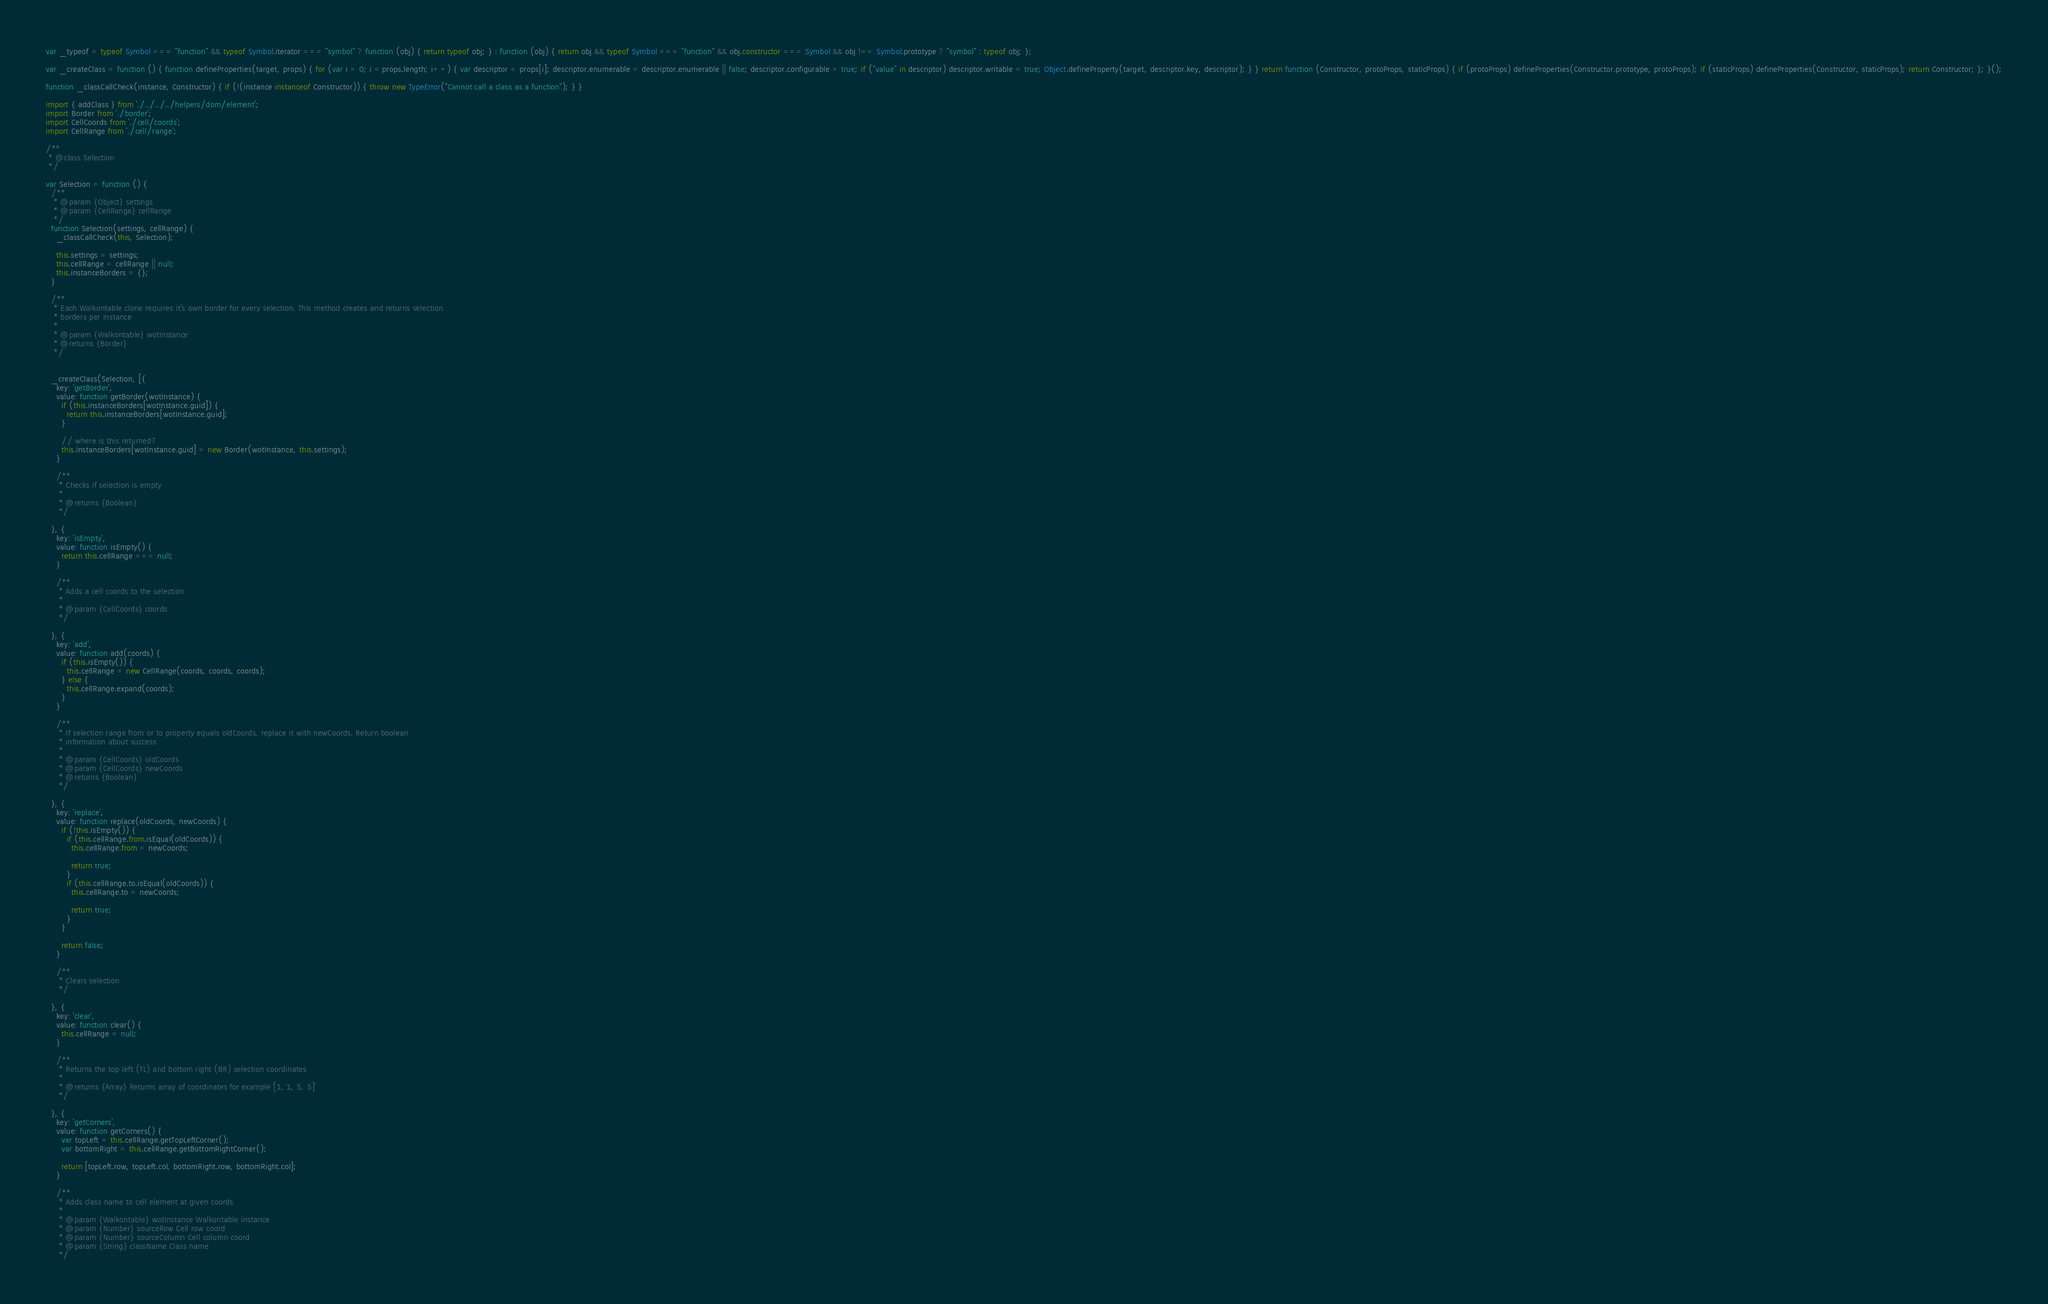Convert code to text. <code><loc_0><loc_0><loc_500><loc_500><_JavaScript_>var _typeof = typeof Symbol === "function" && typeof Symbol.iterator === "symbol" ? function (obj) { return typeof obj; } : function (obj) { return obj && typeof Symbol === "function" && obj.constructor === Symbol && obj !== Symbol.prototype ? "symbol" : typeof obj; };

var _createClass = function () { function defineProperties(target, props) { for (var i = 0; i < props.length; i++) { var descriptor = props[i]; descriptor.enumerable = descriptor.enumerable || false; descriptor.configurable = true; if ("value" in descriptor) descriptor.writable = true; Object.defineProperty(target, descriptor.key, descriptor); } } return function (Constructor, protoProps, staticProps) { if (protoProps) defineProperties(Constructor.prototype, protoProps); if (staticProps) defineProperties(Constructor, staticProps); return Constructor; }; }();

function _classCallCheck(instance, Constructor) { if (!(instance instanceof Constructor)) { throw new TypeError("Cannot call a class as a function"); } }

import { addClass } from './../../../helpers/dom/element';
import Border from './border';
import CellCoords from './cell/coords';
import CellRange from './cell/range';

/**
 * @class Selection
 */

var Selection = function () {
  /**
   * @param {Object} settings
   * @param {CellRange} cellRange
   */
  function Selection(settings, cellRange) {
    _classCallCheck(this, Selection);

    this.settings = settings;
    this.cellRange = cellRange || null;
    this.instanceBorders = {};
  }

  /**
   * Each Walkontable clone requires it's own border for every selection. This method creates and returns selection
   * borders per instance
   *
   * @param {Walkontable} wotInstance
   * @returns {Border}
   */


  _createClass(Selection, [{
    key: 'getBorder',
    value: function getBorder(wotInstance) {
      if (this.instanceBorders[wotInstance.guid]) {
        return this.instanceBorders[wotInstance.guid];
      }

      // where is this returned?
      this.instanceBorders[wotInstance.guid] = new Border(wotInstance, this.settings);
    }

    /**
     * Checks if selection is empty
     *
     * @returns {Boolean}
     */

  }, {
    key: 'isEmpty',
    value: function isEmpty() {
      return this.cellRange === null;
    }

    /**
     * Adds a cell coords to the selection
     *
     * @param {CellCoords} coords
     */

  }, {
    key: 'add',
    value: function add(coords) {
      if (this.isEmpty()) {
        this.cellRange = new CellRange(coords, coords, coords);
      } else {
        this.cellRange.expand(coords);
      }
    }

    /**
     * If selection range from or to property equals oldCoords, replace it with newCoords. Return boolean
     * information about success
     *
     * @param {CellCoords} oldCoords
     * @param {CellCoords} newCoords
     * @returns {Boolean}
     */

  }, {
    key: 'replace',
    value: function replace(oldCoords, newCoords) {
      if (!this.isEmpty()) {
        if (this.cellRange.from.isEqual(oldCoords)) {
          this.cellRange.from = newCoords;

          return true;
        }
        if (this.cellRange.to.isEqual(oldCoords)) {
          this.cellRange.to = newCoords;

          return true;
        }
      }

      return false;
    }

    /**
     * Clears selection
     */

  }, {
    key: 'clear',
    value: function clear() {
      this.cellRange = null;
    }

    /**
     * Returns the top left (TL) and bottom right (BR) selection coordinates
     *
     * @returns {Array} Returns array of coordinates for example `[1, 1, 5, 5]`
     */

  }, {
    key: 'getCorners',
    value: function getCorners() {
      var topLeft = this.cellRange.getTopLeftCorner();
      var bottomRight = this.cellRange.getBottomRightCorner();

      return [topLeft.row, topLeft.col, bottomRight.row, bottomRight.col];
    }

    /**
     * Adds class name to cell element at given coords
     *
     * @param {Walkontable} wotInstance Walkontable instance
     * @param {Number} sourceRow Cell row coord
     * @param {Number} sourceColumn Cell column coord
     * @param {String} className Class name
     */
</code> 